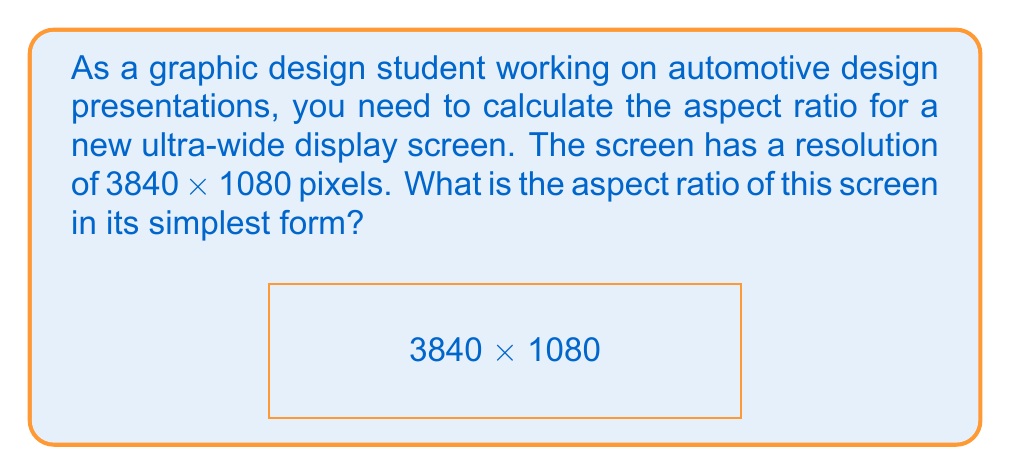Provide a solution to this math problem. To calculate the aspect ratio, we need to follow these steps:

1. Identify the width and height of the screen in pixels:
   Width = 3840 pixels
   Height = 1080 pixels

2. Express the ratio of width to height:
   $$\text{Aspect Ratio} = \frac{\text{Width}}{\text{Height}} = \frac{3840}{1080}$$

3. Simplify the fraction by dividing both the numerator and denominator by their greatest common divisor (GCD):
   $$GCD(3840, 1080) = 120$$

   $$\frac{3840 \div 120}{1080 \div 120} = \frac{32}{9}$$

4. The simplified aspect ratio is 32:9

This ultra-wide aspect ratio is becoming increasingly popular for automotive design work as it provides a panoramic view, allowing designers to showcase vehicle exteriors more effectively.
Answer: 32:9 